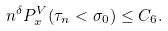Convert formula to latex. <formula><loc_0><loc_0><loc_500><loc_500>n ^ { \delta } P ^ { V } _ { x } ( \tau _ { n } < \sigma _ { 0 } ) \leq C _ { 6 } .</formula> 